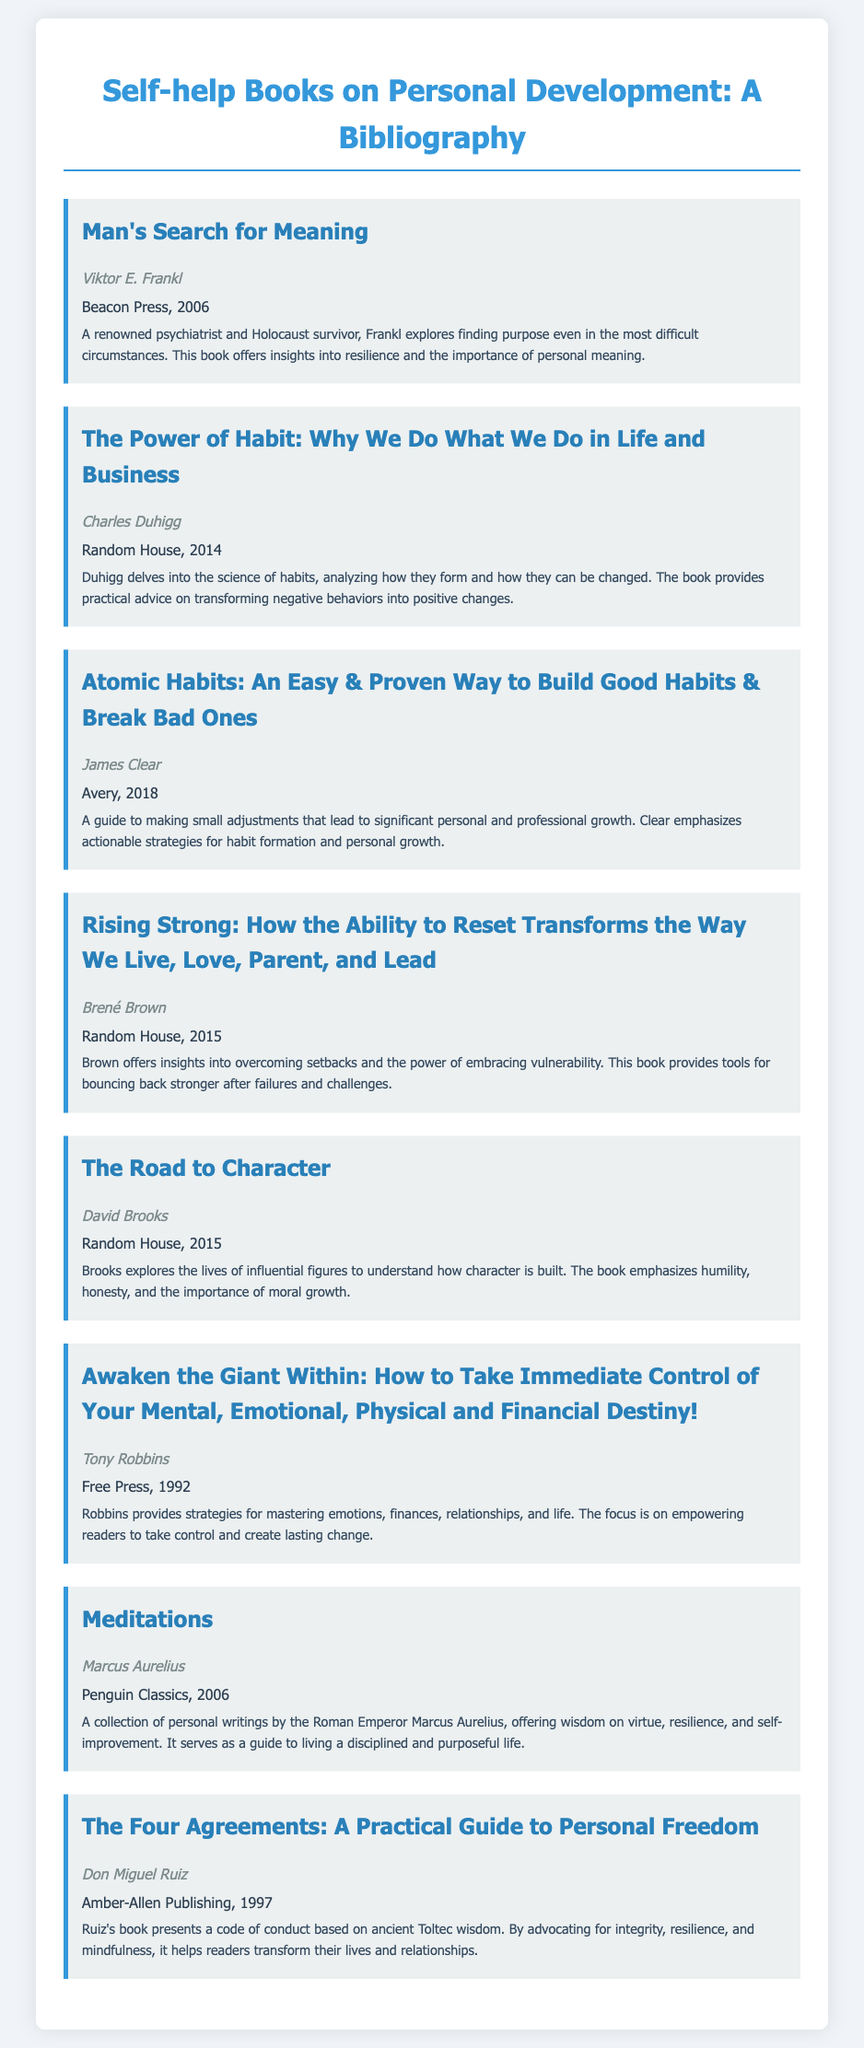what is the title of the first book? The title of the first book listed in the bibliography is "Man's Search for Meaning."
Answer: Man's Search for Meaning who is the author of "Atomic Habits"? The author of "Atomic Habits" is James Clear.
Answer: James Clear what year was "Meditations" published? "Meditations" was published in 2006.
Answer: 2006 which book discusses the importance of personal meaning? "Man's Search for Meaning" discusses the importance of personal meaning.
Answer: Man's Search for Meaning how many books are listed in the bibliography? The total number of books listed in the bibliography is eight.
Answer: eight which book emphasizes actionable strategies for habit formation? "Atomic Habits" emphasizes actionable strategies for habit formation.
Answer: Atomic Habits what is the main theme of "The Power of Habit"? The main theme of "The Power of Habit" is the science of habits and behavior change.
Answer: science of habits who published "The Four Agreements"? "The Four Agreements" was published by Amber-Allen Publishing.
Answer: Amber-Allen Publishing 